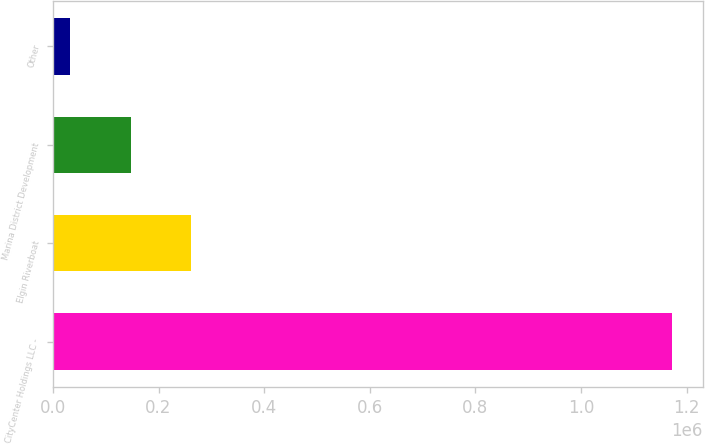<chart> <loc_0><loc_0><loc_500><loc_500><bar_chart><fcel>CityCenter Holdings LLC -<fcel>Elgin Riverboat<fcel>Marina District Development<fcel>Other<nl><fcel>1.17209e+06<fcel>260953<fcel>147062<fcel>33170<nl></chart> 